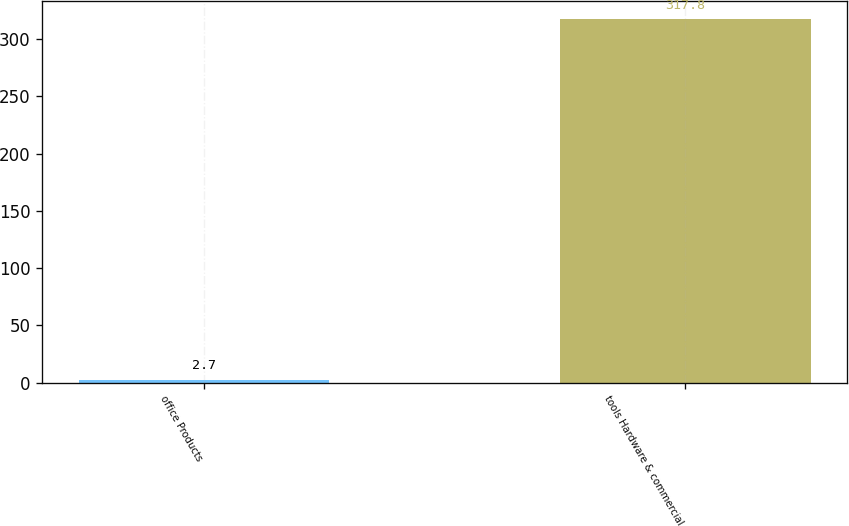Convert chart. <chart><loc_0><loc_0><loc_500><loc_500><bar_chart><fcel>office Products<fcel>tools Hardware & commercial<nl><fcel>2.7<fcel>317.8<nl></chart> 